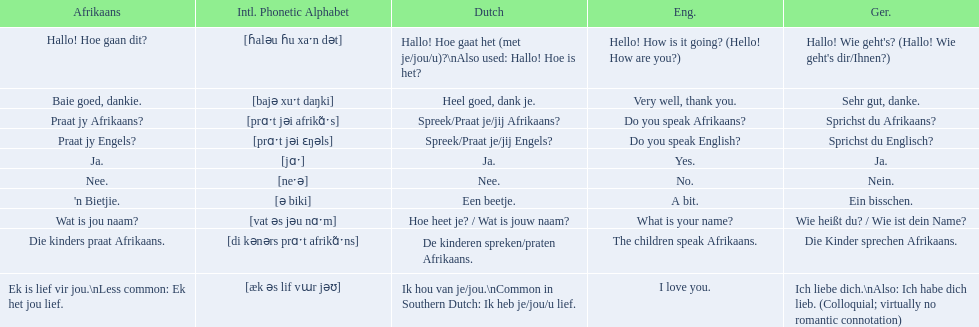In german how do you say do you speak afrikaans? Sprichst du Afrikaans?. How do you say it in afrikaans? Praat jy Afrikaans?. 